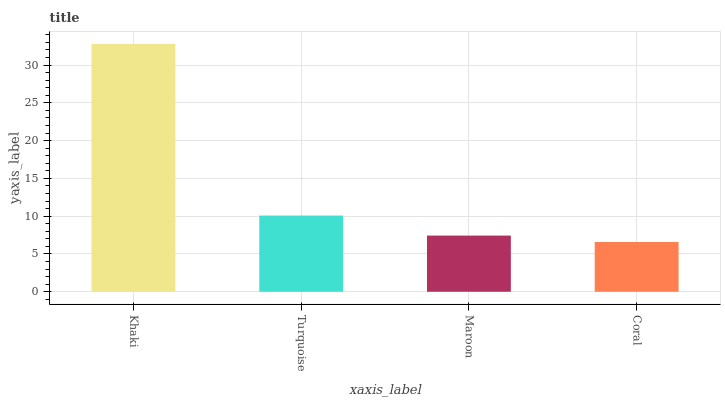Is Coral the minimum?
Answer yes or no. Yes. Is Khaki the maximum?
Answer yes or no. Yes. Is Turquoise the minimum?
Answer yes or no. No. Is Turquoise the maximum?
Answer yes or no. No. Is Khaki greater than Turquoise?
Answer yes or no. Yes. Is Turquoise less than Khaki?
Answer yes or no. Yes. Is Turquoise greater than Khaki?
Answer yes or no. No. Is Khaki less than Turquoise?
Answer yes or no. No. Is Turquoise the high median?
Answer yes or no. Yes. Is Maroon the low median?
Answer yes or no. Yes. Is Maroon the high median?
Answer yes or no. No. Is Turquoise the low median?
Answer yes or no. No. 